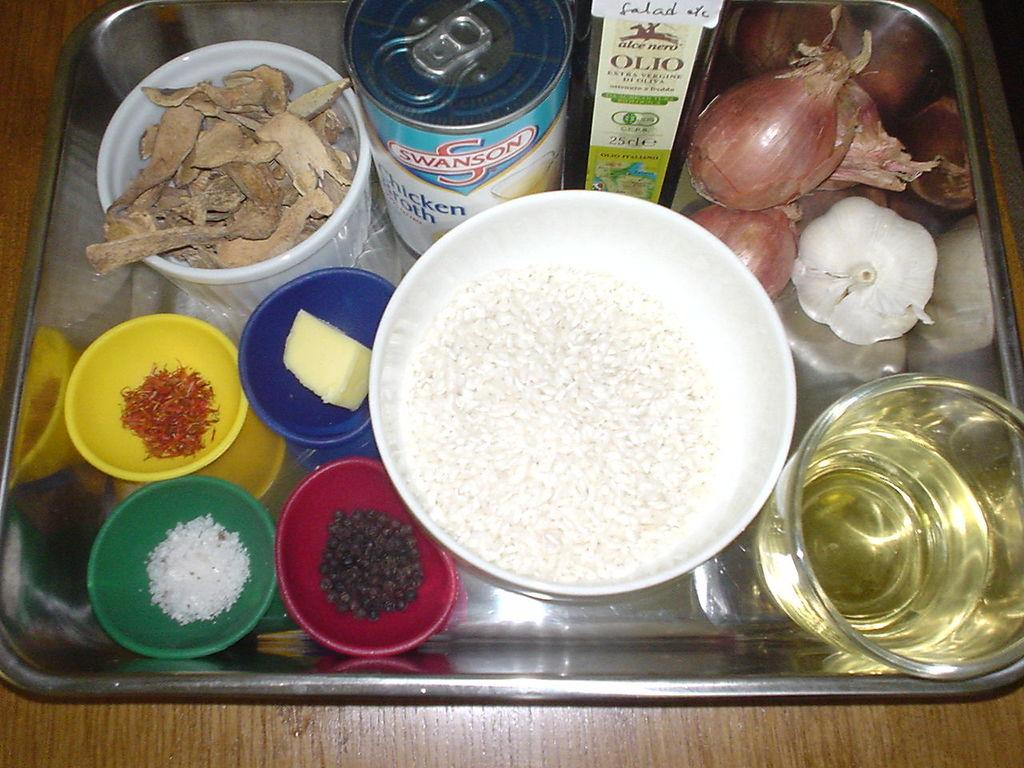What is the main piece of furniture in the image? There is a table in the image. What is placed on the table? There are food items placed on a tray on the table. Where is the cushion located in the image? There is no cushion present in the image. What type of milk can be seen in the image? There is no milk present in the image. 